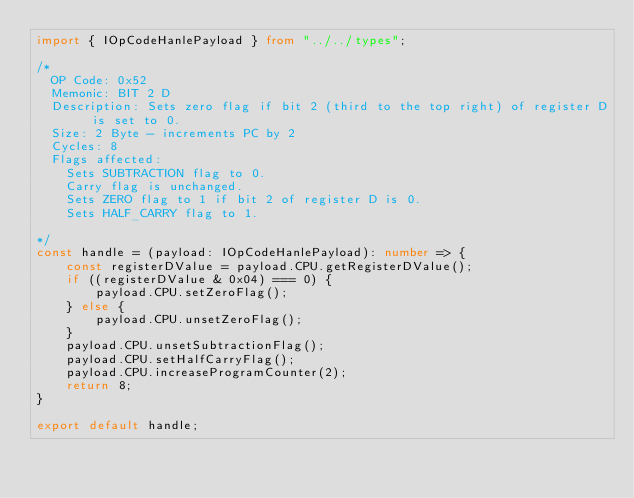Convert code to text. <code><loc_0><loc_0><loc_500><loc_500><_TypeScript_>import { IOpCodeHanlePayload } from "../../types";

/*
  OP Code: 0x52
  Memonic: BIT 2 D
  Description: Sets zero flag if bit 2 (third to the top right) of register D is set to 0.
  Size: 2 Byte - increments PC by 2
  Cycles: 8
  Flags affected:
    Sets SUBTRACTION flag to 0.
    Carry flag is unchanged.
    Sets ZERO flag to 1 if bit 2 of register D is 0.
    Sets HALF_CARRY flag to 1.

*/
const handle = (payload: IOpCodeHanlePayload): number => {
    const registerDValue = payload.CPU.getRegisterDValue();
    if ((registerDValue & 0x04) === 0) {
        payload.CPU.setZeroFlag();
    } else {
        payload.CPU.unsetZeroFlag();
    }
    payload.CPU.unsetSubtractionFlag();
    payload.CPU.setHalfCarryFlag();
    payload.CPU.increaseProgramCounter(2);
    return 8;
}

export default handle;</code> 